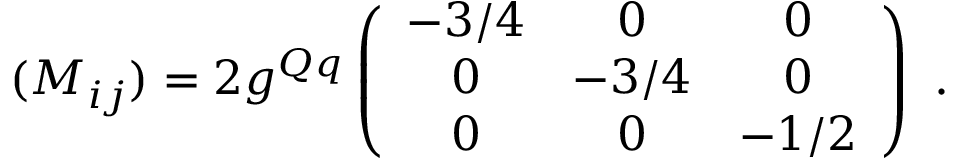Convert formula to latex. <formula><loc_0><loc_0><loc_500><loc_500>( M _ { i j } ) = 2 g ^ { Q q } \left ( \begin{array} { c c c } { - 3 / 4 } & { 0 } & { 0 } \\ { 0 } & { - 3 / 4 } & { 0 } \\ { 0 } & { 0 } & { - 1 / 2 } \end{array} \right ) \ .</formula> 